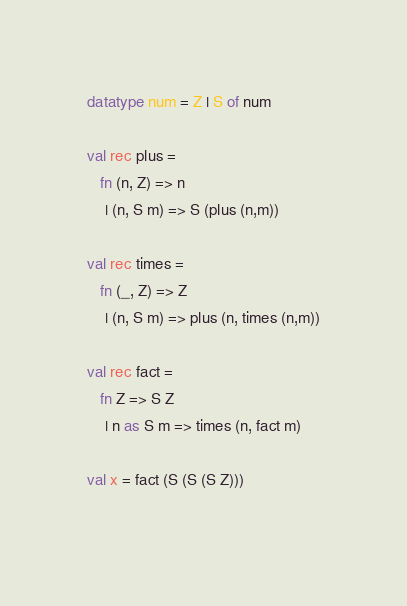Convert code to text. <code><loc_0><loc_0><loc_500><loc_500><_SML_>datatype num = Z | S of num

val rec plus =
   fn (n, Z) => n
    | (n, S m) => S (plus (n,m))

val rec times =
   fn (_, Z) => Z
    | (n, S m) => plus (n, times (n,m))

val rec fact =
   fn Z => S Z
    | n as S m => times (n, fact m)

val x = fact (S (S (S Z)))
	      
</code> 